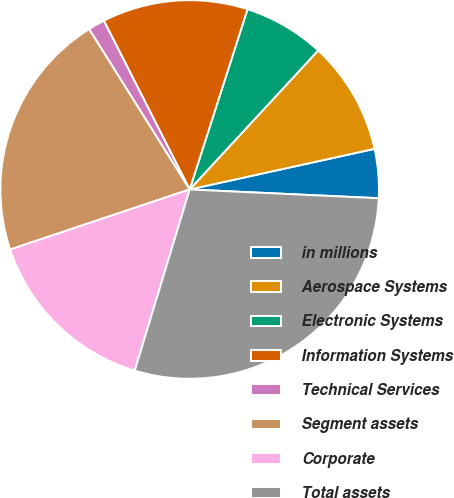Convert chart to OTSL. <chart><loc_0><loc_0><loc_500><loc_500><pie_chart><fcel>in millions<fcel>Aerospace Systems<fcel>Electronic Systems<fcel>Information Systems<fcel>Technical Services<fcel>Segment assets<fcel>Corporate<fcel>Total assets<nl><fcel>4.18%<fcel>9.68%<fcel>6.93%<fcel>12.43%<fcel>1.43%<fcel>21.22%<fcel>15.18%<fcel>28.94%<nl></chart> 